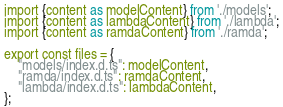<code> <loc_0><loc_0><loc_500><loc_500><_JavaScript_>import {content as modelContent} from './models';
import {content as lambdaContent} from './lambda';
import {content as ramdaContent} from './ramda';

export const files = {
    "models/index.d.ts": modelContent,
    "ramda/index.d.ts": ramdaContent,
    "lambda/index.d.ts": lambdaContent,
};
</code> 